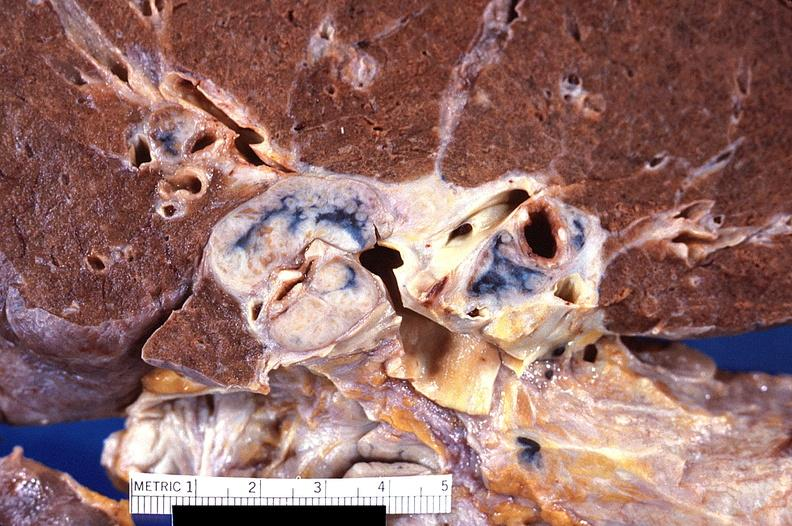where is this?
Answer the question using a single word or phrase. Lung 